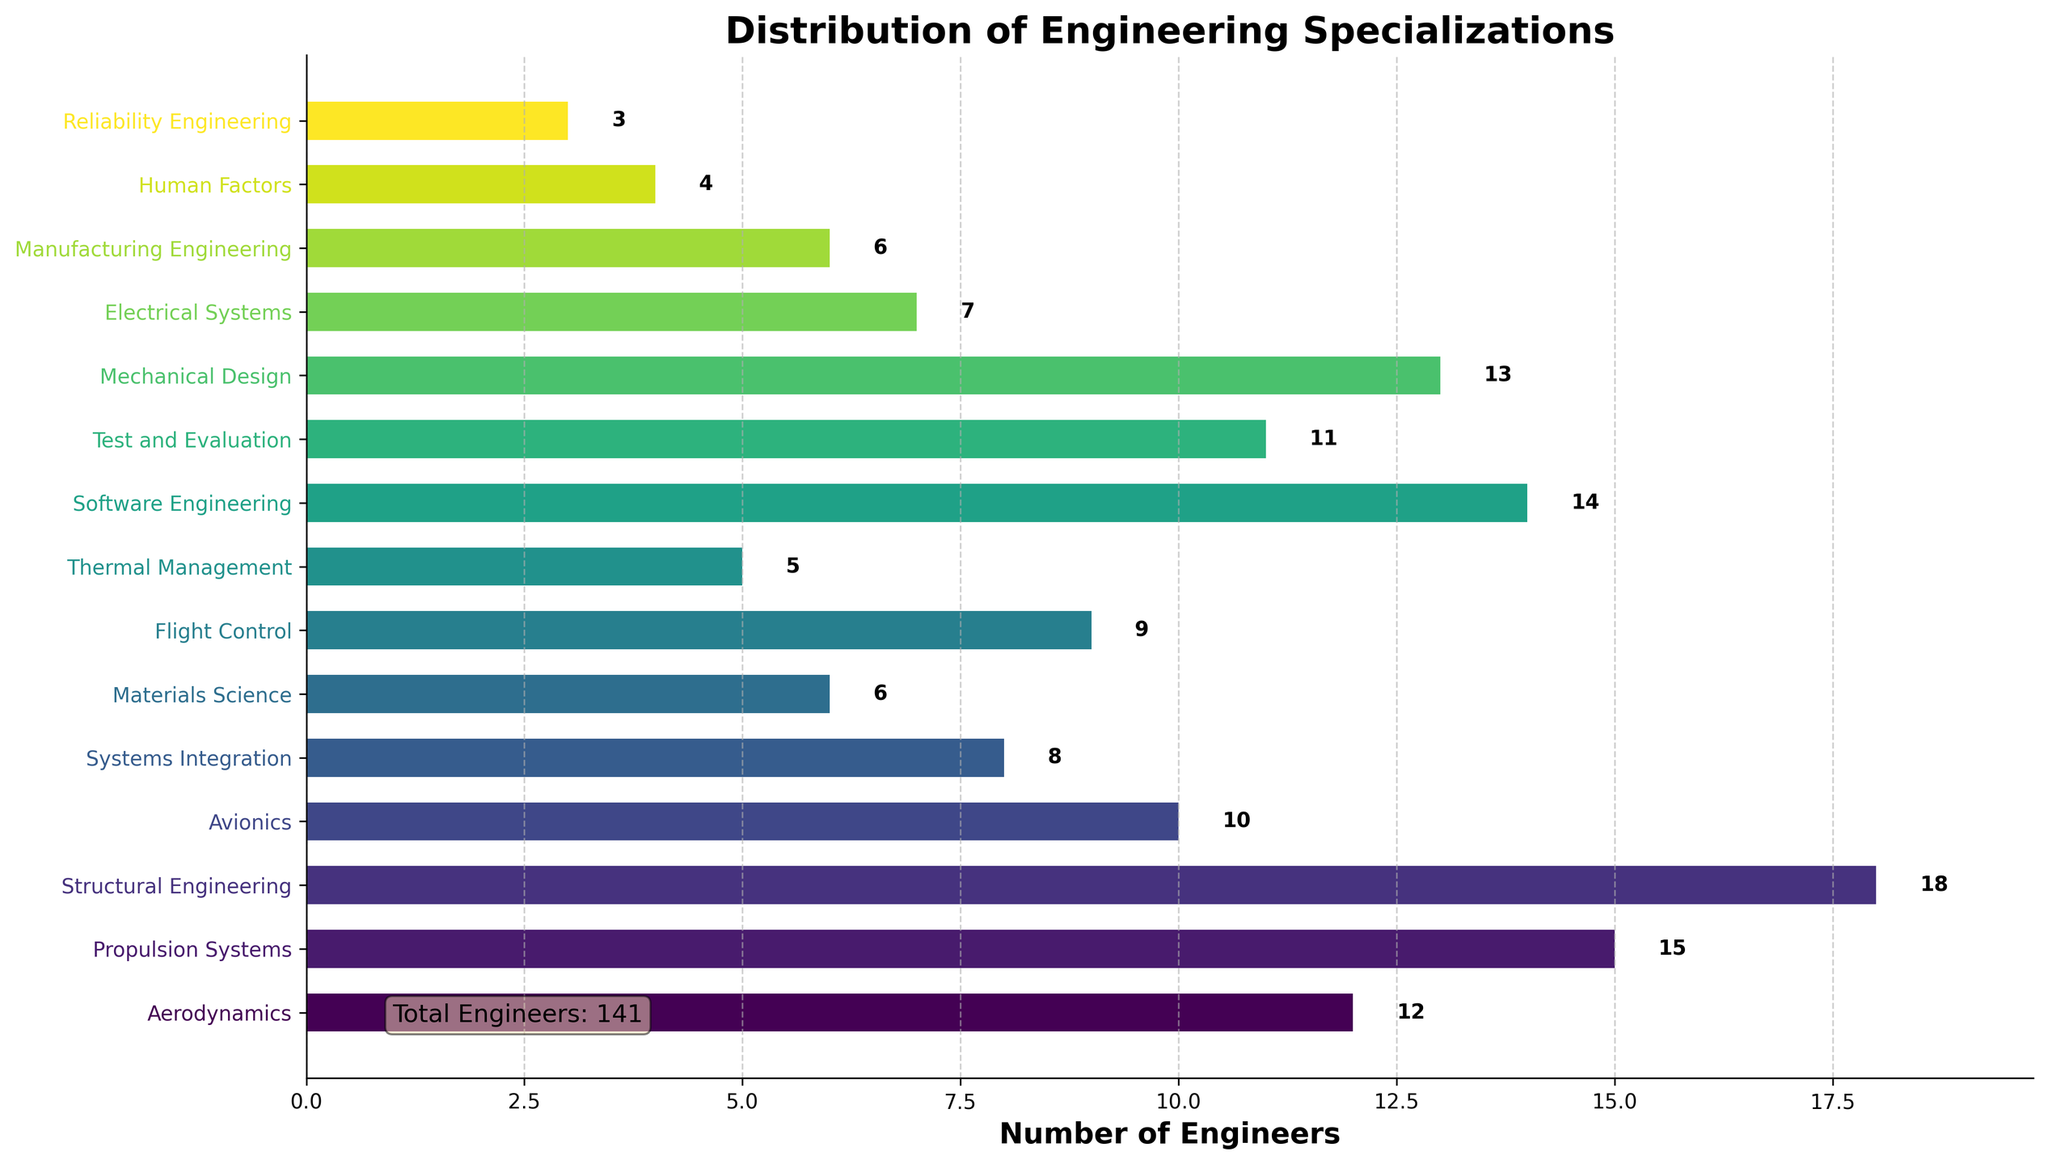Which specialization has the highest number of engineers? Examine the bar chart carefully; the tallest bar will represent the specialization with the highest number of engineers. In this case, the tallest bar corresponds to Structural Engineering.
Answer: Structural Engineering How many more engineers are in Propulsion Systems compared to Flight Control? Identify the counts for Propulsion Systems and Flight Control from the chart (15 and 9, respectively). Subtract the number of engineers in Flight Control from Propulsion Systems (15 - 9).
Answer: 6 What is the total number of engineers in Aerodynamics, Avionics, and Electrical Systems combined? Find and add the number of engineers in Aerodynamics (12), Avionics (10), and Electrical Systems (7) from the chart. The sum is 12 + 10 + 7.
Answer: 29 Which specialization has the least number of engineers, and how many does it have? Identify the shortest bar on the chart. The shortest bar represents Reliability Engineering, which has the smallest value on the x-axis.
Answer: Reliability Engineering, 3 How does the number of engineers in Software Engineering compare with that in Mechanical Design? Locate the bars for Software Engineering and Mechanical Design on the chart. The bar for Software Engineering shows 14, and the bar for Mechanical Design shows 13. Hence, Software Engineering has one more engineer than Mechanical Design.
Answer: Software Engineering has 1 more engineer How many specializations have more than 10 engineers? Count the bars that extend beyond the 10-engineer mark. Specializations like Aerodynamics, Propulsion Systems, Structural Engineering, Software Engineering, Test and Evaluation, and Mechanical Design.
Answer: 6 What's the difference between the specialization with the most engineers and the one with the least? Identify the counts for Structural Engineering (18) and Reliability Engineering (3). Subtract the smaller count from the larger one (18 - 3).
Answer: 15 If we were to average the number of engineers across all specializations, what would that be approximately? Calculate the sum of engineers across all specializations (sum the provided numbers) and then divide by the total number of specializations (15). The sum is 12 + 15 + 18 + 10 + 8 + 6 + 9 + 5 + 14 + 11 + 13 + 7 + 6 + 4 + 3 = 141. The average is 141/15.
Answer: 9.4 Which specialized area appears visually distinct due to its color, and what is the number associated with it? Look for a bar that stands out because of its color. Different specializations will have different colors based on the color palette. Assume a notable color difference is more prominent; let's take Thermal Management for example, which is shorter and might have a distinct color. It has 5 engineers.
Answer: Thermal Management, 5 